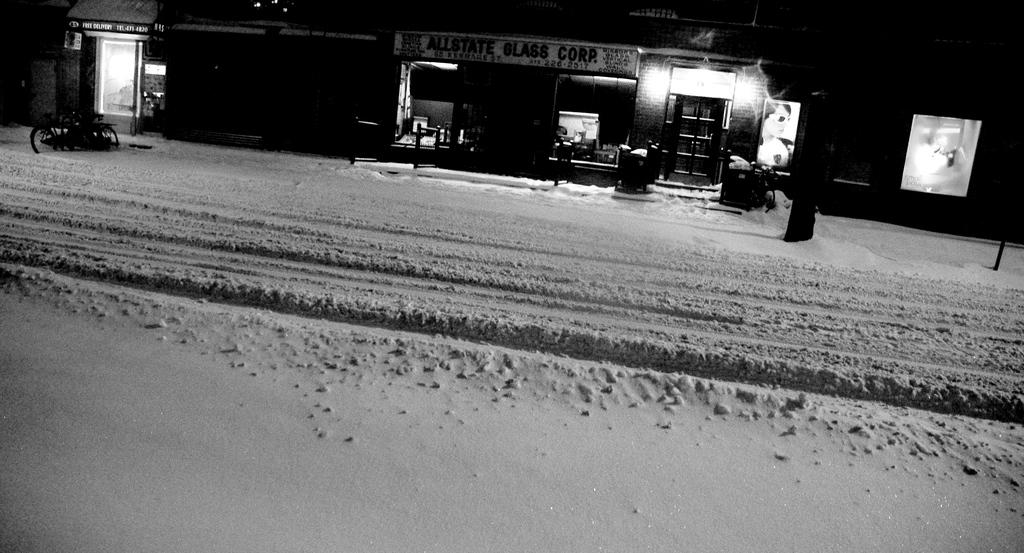What type of structures can be seen in the image? There are buildings in the image. What is the main feature of the landscape in the image? There is a road in the image. How is the road affected by the weather in the image? The road is covered with snow. What news can be heard coming from the buildings in the image? There is no indication in the image that any news is being broadcast from the buildings. 